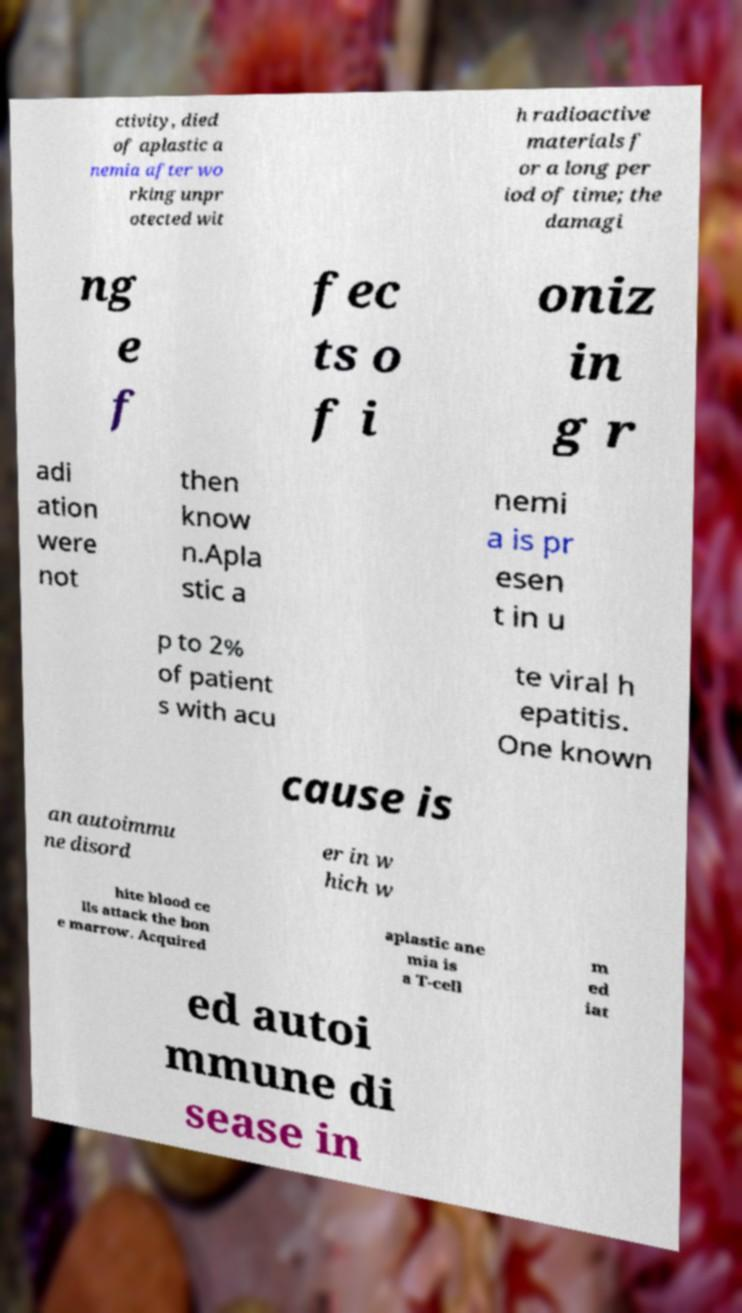Can you accurately transcribe the text from the provided image for me? ctivity, died of aplastic a nemia after wo rking unpr otected wit h radioactive materials f or a long per iod of time; the damagi ng e f fec ts o f i oniz in g r adi ation were not then know n.Apla stic a nemi a is pr esen t in u p to 2% of patient s with acu te viral h epatitis. One known cause is an autoimmu ne disord er in w hich w hite blood ce lls attack the bon e marrow. Acquired aplastic ane mia is a T-cell m ed iat ed autoi mmune di sease in 